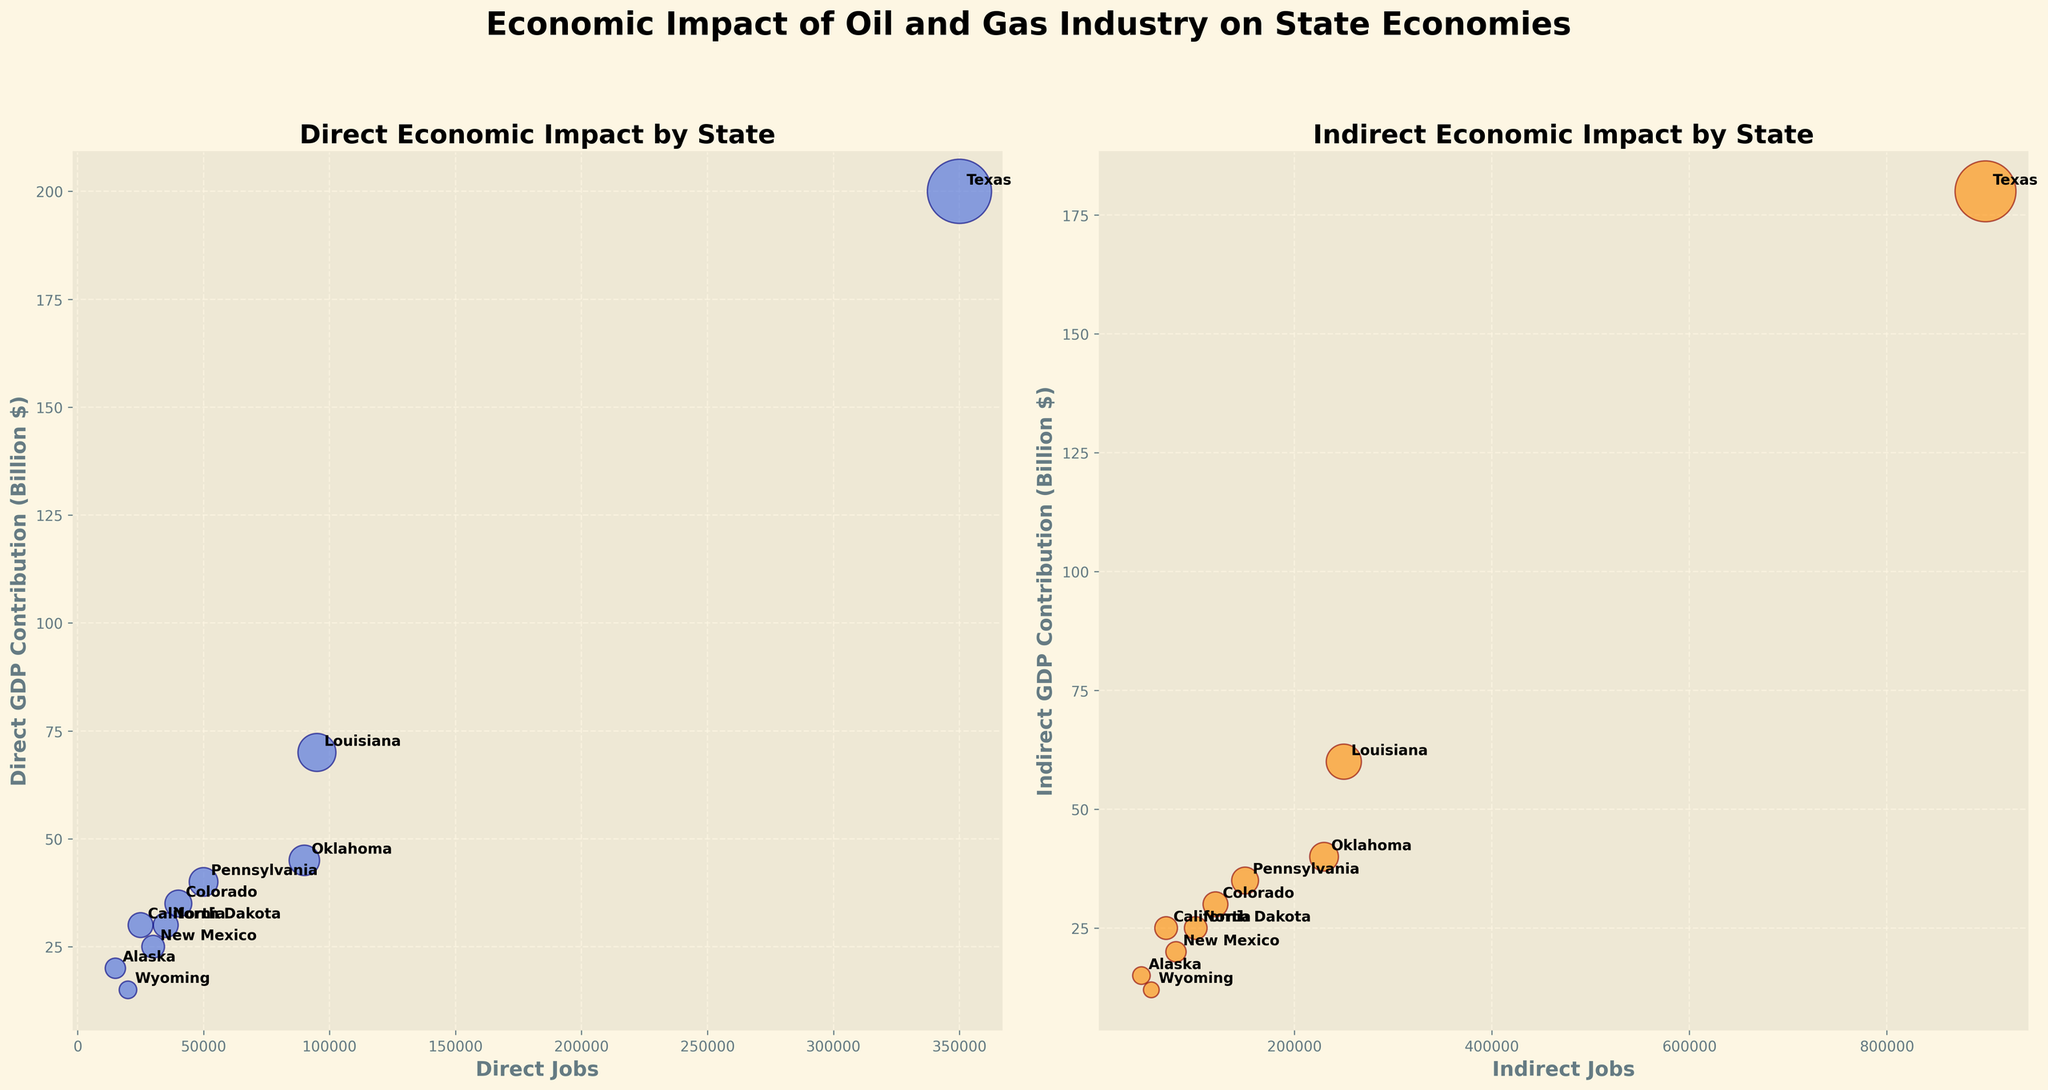How many states are represented in the charts? We can count the number of unique states annotated next to each data point in both subplots. We count a total of 10 states.
Answer: 10 Which state has the highest direct GDP contribution? We look at the vertical axis of the left subplot and identify which state corresponds to the highest point. Texas has the highest direct GDP contribution with 200 billion dollars.
Answer: Texas Which state has the least indirect employment? We look at the horizontal axis of the right subplot and identify the state that corresponds to the smallest value. Alaska has the least indirect jobs.
Answer: Alaska Compare the total economic impact (combination of direct and indirect GDP contributions) for Texas and Pennsylvania. Which one is higher? We need to add the direct and indirect GDP contributions for each state and compare them. For Texas, it’s 200 + 180 = 380 billion dollars. For Pennsylvania, it’s 40 + 35 = 75 billion dollars. Texas has a higher total economic impact.
Answer: Texas What is the range of direct jobs across all the states represented? To find the range, we need to identify the highest and lowest values on the horizontal axis of the left subplot. The highest is 350,000 (Texas), and the lowest is 15,000 (Alaska). The range is 350,000 - 15,000 = 335,000.
Answer: 335,000 How does New Mexico’s indirect GDP contribution compare to its direct GDP contribution? On the right subplot, find New Mexico and note its indirect GDP contribution (20 billion $). On the left subplot, find New Mexico and note its direct GDP contribution (25 billion $). New Mexico’s indirect GDP contribution is 5 billion dollars less than its direct GDP contribution.
Answer: Indirect is less by 5 billion $ Which state has the largest bubble in the indirect contributions chart and what does it represent? By identifying the size of the bubbles in the right subplot, we see that Texas has the largest bubble. This represents the highest indirect GDP contribution.
Answer: Texas Is there a direct correlation between states with high direct GDP contributions and high indirect GDP contributions? To determine the correlation, observe states that are high on both charts. Texas, Louisiana, and Oklahoma, for example, appear high on both subplots, indicating a positive correlation.
Answer: Yes How does Colorado's total economic impact compare to New Mexico's total economic impact? By looking at the sum of direct and indirect GDP contributions on both subplots, Colorado’s total impact is 35 + 30 = 65 billion dollars, while New Mexico’s is 25 + 20 = 45 billion dollars. Colorado’s total economic impact is higher by 20 billion dollars.
Answer: Colorado is higher by 20 billion $ Which state has the smallest direct GDP contribution, and how does its indirect GDP contribution compare? From the left subplot, the smallest direct GDP contribution is Wyoming with 15 billion dollars. On the right subplot, Wyoming’s indirect GDP contribution is 12 billion dollars. The indirect GDP contribution is 3 billion dollars less than the direct.
Answer: Wyoming, indirect is less by 3 billion $ 